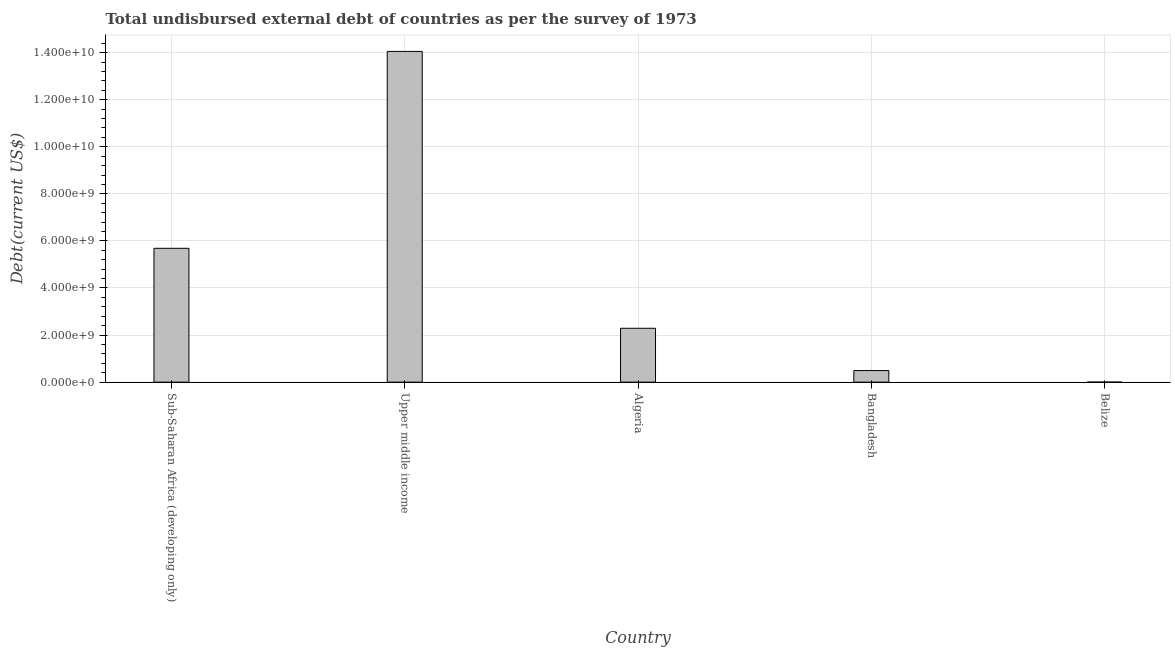Does the graph contain any zero values?
Ensure brevity in your answer.  No. Does the graph contain grids?
Your answer should be very brief. Yes. What is the title of the graph?
Offer a very short reply. Total undisbursed external debt of countries as per the survey of 1973. What is the label or title of the X-axis?
Give a very brief answer. Country. What is the label or title of the Y-axis?
Ensure brevity in your answer.  Debt(current US$). What is the total debt in Bangladesh?
Your response must be concise. 4.92e+08. Across all countries, what is the maximum total debt?
Make the answer very short. 1.41e+1. Across all countries, what is the minimum total debt?
Offer a very short reply. 8.95e+05. In which country was the total debt maximum?
Your response must be concise. Upper middle income. In which country was the total debt minimum?
Provide a short and direct response. Belize. What is the sum of the total debt?
Offer a terse response. 2.25e+1. What is the difference between the total debt in Bangladesh and Sub-Saharan Africa (developing only)?
Provide a succinct answer. -5.19e+09. What is the average total debt per country?
Offer a very short reply. 4.50e+09. What is the median total debt?
Keep it short and to the point. 2.29e+09. In how many countries, is the total debt greater than 2000000000 US$?
Ensure brevity in your answer.  3. What is the ratio of the total debt in Algeria to that in Belize?
Provide a succinct answer. 2557.13. Is the difference between the total debt in Algeria and Upper middle income greater than the difference between any two countries?
Provide a succinct answer. No. What is the difference between the highest and the second highest total debt?
Provide a short and direct response. 8.36e+09. Is the sum of the total debt in Algeria and Upper middle income greater than the maximum total debt across all countries?
Provide a succinct answer. Yes. What is the difference between the highest and the lowest total debt?
Make the answer very short. 1.40e+1. In how many countries, is the total debt greater than the average total debt taken over all countries?
Keep it short and to the point. 2. How many countries are there in the graph?
Keep it short and to the point. 5. What is the Debt(current US$) in Sub-Saharan Africa (developing only)?
Your answer should be compact. 5.69e+09. What is the Debt(current US$) of Upper middle income?
Give a very brief answer. 1.41e+1. What is the Debt(current US$) of Algeria?
Provide a succinct answer. 2.29e+09. What is the Debt(current US$) in Bangladesh?
Give a very brief answer. 4.92e+08. What is the Debt(current US$) in Belize?
Your response must be concise. 8.95e+05. What is the difference between the Debt(current US$) in Sub-Saharan Africa (developing only) and Upper middle income?
Provide a succinct answer. -8.36e+09. What is the difference between the Debt(current US$) in Sub-Saharan Africa (developing only) and Algeria?
Keep it short and to the point. 3.40e+09. What is the difference between the Debt(current US$) in Sub-Saharan Africa (developing only) and Bangladesh?
Ensure brevity in your answer.  5.19e+09. What is the difference between the Debt(current US$) in Sub-Saharan Africa (developing only) and Belize?
Ensure brevity in your answer.  5.69e+09. What is the difference between the Debt(current US$) in Upper middle income and Algeria?
Make the answer very short. 1.18e+1. What is the difference between the Debt(current US$) in Upper middle income and Bangladesh?
Your answer should be compact. 1.36e+1. What is the difference between the Debt(current US$) in Upper middle income and Belize?
Make the answer very short. 1.40e+1. What is the difference between the Debt(current US$) in Algeria and Bangladesh?
Ensure brevity in your answer.  1.80e+09. What is the difference between the Debt(current US$) in Algeria and Belize?
Ensure brevity in your answer.  2.29e+09. What is the difference between the Debt(current US$) in Bangladesh and Belize?
Make the answer very short. 4.91e+08. What is the ratio of the Debt(current US$) in Sub-Saharan Africa (developing only) to that in Upper middle income?
Your answer should be compact. 0.41. What is the ratio of the Debt(current US$) in Sub-Saharan Africa (developing only) to that in Algeria?
Offer a terse response. 2.48. What is the ratio of the Debt(current US$) in Sub-Saharan Africa (developing only) to that in Bangladesh?
Offer a terse response. 11.55. What is the ratio of the Debt(current US$) in Sub-Saharan Africa (developing only) to that in Belize?
Keep it short and to the point. 6352.98. What is the ratio of the Debt(current US$) in Upper middle income to that in Algeria?
Provide a short and direct response. 6.14. What is the ratio of the Debt(current US$) in Upper middle income to that in Bangladesh?
Your answer should be compact. 28.54. What is the ratio of the Debt(current US$) in Upper middle income to that in Belize?
Make the answer very short. 1.57e+04. What is the ratio of the Debt(current US$) in Algeria to that in Bangladesh?
Keep it short and to the point. 4.65. What is the ratio of the Debt(current US$) in Algeria to that in Belize?
Offer a very short reply. 2557.13. What is the ratio of the Debt(current US$) in Bangladesh to that in Belize?
Give a very brief answer. 550.04. 